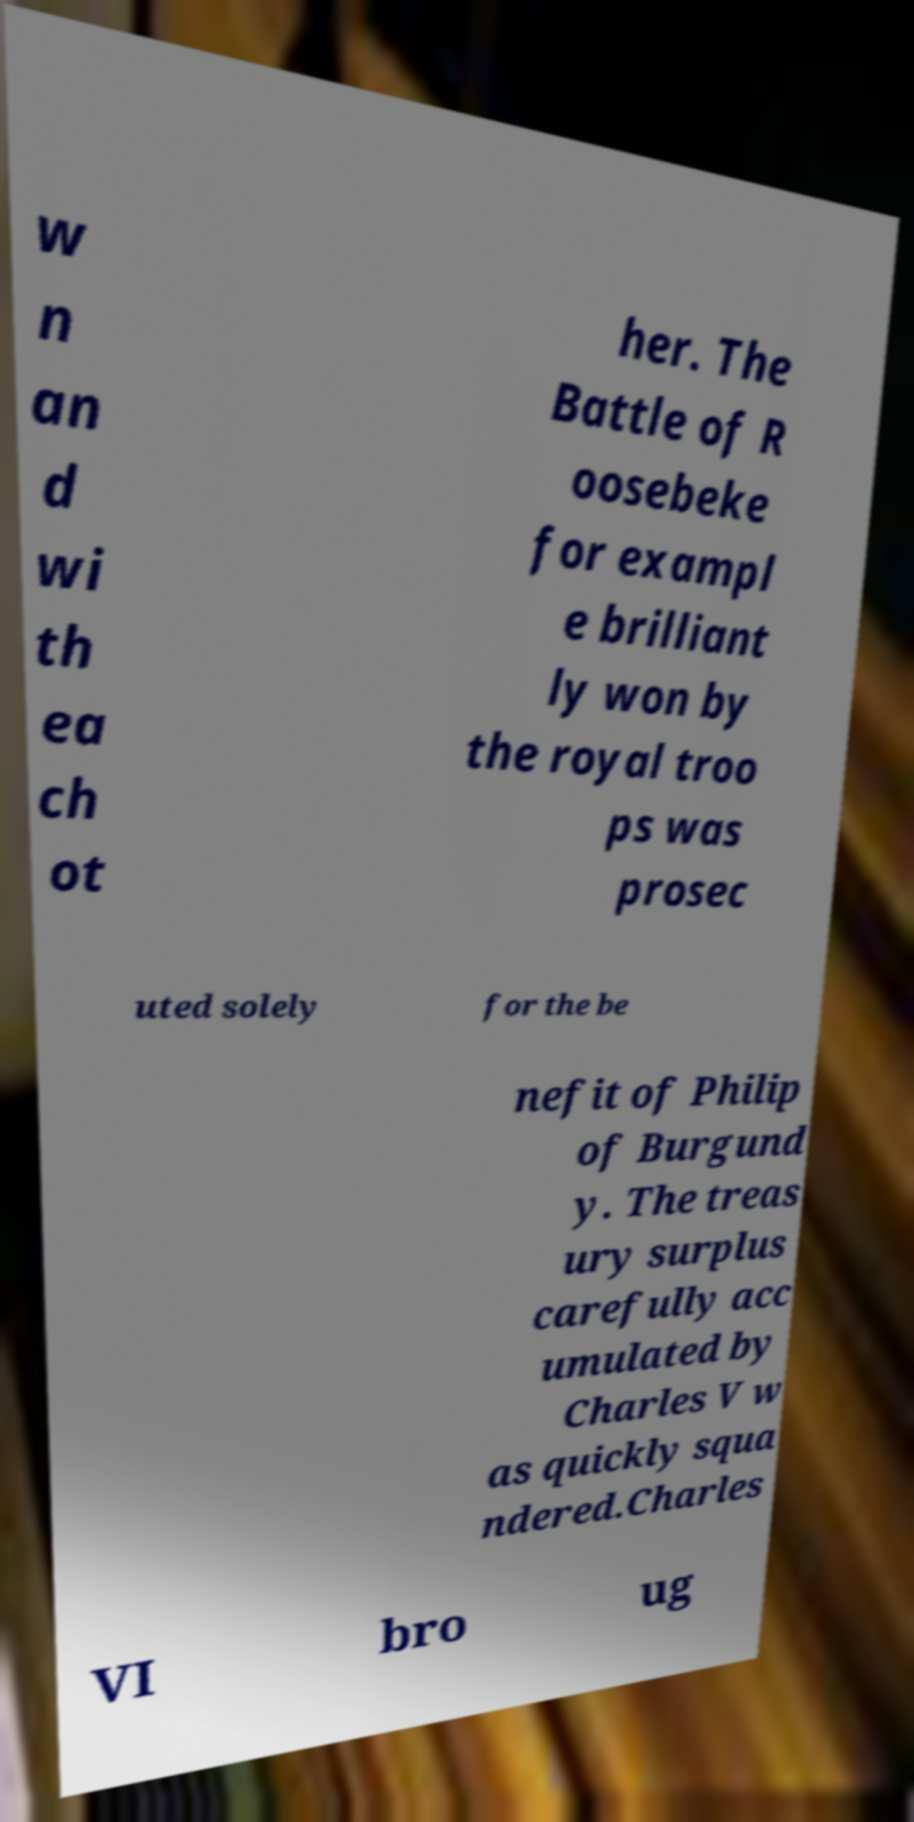There's text embedded in this image that I need extracted. Can you transcribe it verbatim? w n an d wi th ea ch ot her. The Battle of R oosebeke for exampl e brilliant ly won by the royal troo ps was prosec uted solely for the be nefit of Philip of Burgund y. The treas ury surplus carefully acc umulated by Charles V w as quickly squa ndered.Charles VI bro ug 